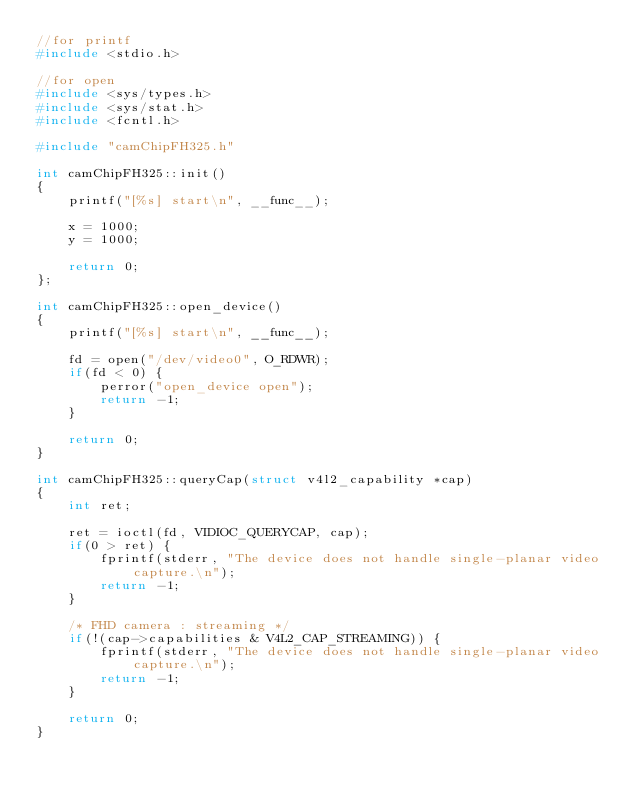<code> <loc_0><loc_0><loc_500><loc_500><_C++_>//for printf
#include <stdio.h>

//for open
#include <sys/types.h>
#include <sys/stat.h>
#include <fcntl.h>

#include "camChipFH325.h"

int camChipFH325::init()
{
	printf("[%s] start\n", __func__);

	x = 1000;
	y = 1000;

	return 0;
};

int camChipFH325::open_device()
{
	printf("[%s] start\n", __func__);

	fd = open("/dev/video0", O_RDWR);
	if(fd < 0) {
		perror("open_device open");
		return -1;
	}

	return 0;
}

int camChipFH325::queryCap(struct v4l2_capability *cap)
{
	int ret;

	ret = ioctl(fd, VIDIOC_QUERYCAP, cap);
	if(0 > ret) {
		fprintf(stderr, "The device does not handle single-planar video capture.\n");
		return -1;
	}

	/* FHD camera : streaming */
	if(!(cap->capabilities & V4L2_CAP_STREAMING)) {
		fprintf(stderr, "The device does not handle single-planar video capture.\n");
		return -1;
	}

	return 0;
}

</code> 